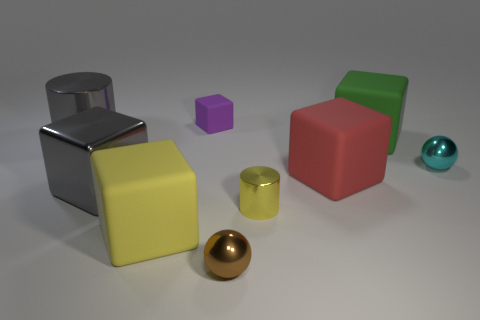Do the cylinder on the right side of the small purple matte block and the large matte block on the left side of the purple cube have the same color?
Offer a terse response. Yes. There is a large cylinder that is the same color as the metallic cube; what is its material?
Provide a short and direct response. Metal. There is a red object that is made of the same material as the big green thing; what shape is it?
Your response must be concise. Cube. Are there more cylinders behind the yellow rubber thing than rubber cubes to the left of the small purple block?
Your answer should be very brief. Yes. What number of things are either large purple cubes or big rubber cubes?
Make the answer very short. 3. What number of other objects are there of the same color as the metal cube?
Give a very brief answer. 1. There is a purple thing that is the same size as the cyan metal sphere; what shape is it?
Your response must be concise. Cube. There is a shiny ball behind the large yellow object; what color is it?
Give a very brief answer. Cyan. What number of things are either cylinders left of the tiny yellow object or metallic cylinders on the left side of the cyan shiny ball?
Your response must be concise. 2. Does the yellow metal cylinder have the same size as the red matte thing?
Your response must be concise. No. 